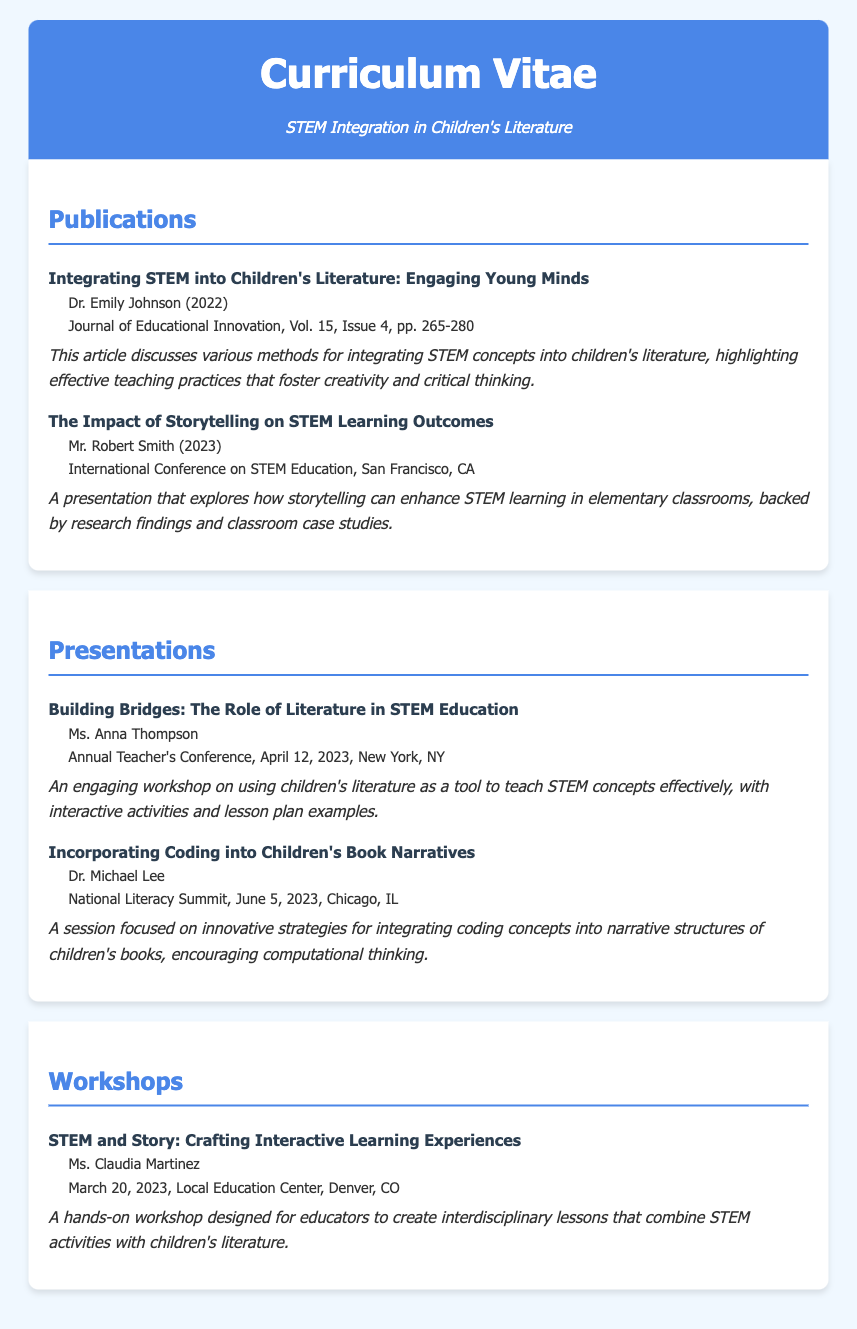what is the title of the first publication? The title is found in the publications section, specifically for Dr. Emily Johnson's work from 2022.
Answer: Integrating STEM into Children's Literature: Engaging Young Minds who presented at the Annual Teacher's Conference in April 2023? The presenter's name is listed under presentations for the conference taking place in New York.
Answer: Ms. Anna Thompson what is the date of the workshop led by Ms. Claudia Martinez? The date is mentioned in the workshops section of the document.
Answer: March 20, 2023 who are the authors mentioned in the publications section? The authors' names appear next to their respective publication titles, showcasing their contributions.
Answer: Dr. Emily Johnson, Mr. Robert Smith what is the main focus of the presentation titled "Incorporating Coding into Children's Book Narratives"? The focus can be inferred from the description provided under the respective presentation entry.
Answer: Innovative strategies for integrating coding concepts how many pages does Dr. Emily Johnson's article cover in the Journal of Educational Innovation? The page number range is specified in the citation for the article in the publications section.
Answer: pp. 265-280 which conference was the presentation on storytelling held? The name of the conference is noted alongside the presentation details within the document.
Answer: International Conference on STEM Education how is storytelling connected to STEM learning according to the second publication? The connection is derived from the description that discusses the impact of storytelling on learning outcomes.
Answer: Enhances STEM learning which workshop focuses on creating interdisciplinary lessons? The title of the workshop is provided in the workshops section, clearly indicating its purpose.
Answer: STEM and Story: Crafting Interactive Learning Experiences 